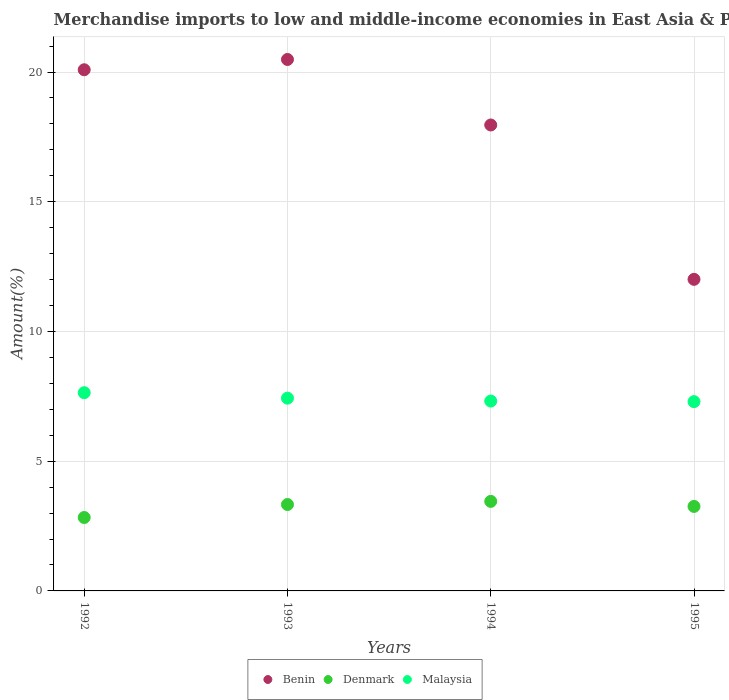How many different coloured dotlines are there?
Your answer should be very brief. 3. What is the percentage of amount earned from merchandise imports in Benin in 1993?
Make the answer very short. 20.48. Across all years, what is the maximum percentage of amount earned from merchandise imports in Denmark?
Give a very brief answer. 3.45. Across all years, what is the minimum percentage of amount earned from merchandise imports in Benin?
Give a very brief answer. 12.01. In which year was the percentage of amount earned from merchandise imports in Denmark maximum?
Ensure brevity in your answer.  1994. In which year was the percentage of amount earned from merchandise imports in Benin minimum?
Keep it short and to the point. 1995. What is the total percentage of amount earned from merchandise imports in Malaysia in the graph?
Give a very brief answer. 29.68. What is the difference between the percentage of amount earned from merchandise imports in Malaysia in 1994 and that in 1995?
Your answer should be very brief. 0.02. What is the difference between the percentage of amount earned from merchandise imports in Malaysia in 1992 and the percentage of amount earned from merchandise imports in Benin in 1994?
Your answer should be very brief. -10.32. What is the average percentage of amount earned from merchandise imports in Denmark per year?
Make the answer very short. 3.22. In the year 1993, what is the difference between the percentage of amount earned from merchandise imports in Benin and percentage of amount earned from merchandise imports in Malaysia?
Provide a succinct answer. 13.05. In how many years, is the percentage of amount earned from merchandise imports in Benin greater than 11 %?
Your answer should be very brief. 4. What is the ratio of the percentage of amount earned from merchandise imports in Denmark in 1992 to that in 1995?
Give a very brief answer. 0.87. Is the percentage of amount earned from merchandise imports in Benin in 1993 less than that in 1995?
Your answer should be compact. No. Is the difference between the percentage of amount earned from merchandise imports in Benin in 1992 and 1994 greater than the difference between the percentage of amount earned from merchandise imports in Malaysia in 1992 and 1994?
Offer a very short reply. Yes. What is the difference between the highest and the second highest percentage of amount earned from merchandise imports in Malaysia?
Your answer should be very brief. 0.21. What is the difference between the highest and the lowest percentage of amount earned from merchandise imports in Malaysia?
Your answer should be compact. 0.34. In how many years, is the percentage of amount earned from merchandise imports in Malaysia greater than the average percentage of amount earned from merchandise imports in Malaysia taken over all years?
Provide a succinct answer. 2. Is the sum of the percentage of amount earned from merchandise imports in Benin in 1993 and 1994 greater than the maximum percentage of amount earned from merchandise imports in Denmark across all years?
Make the answer very short. Yes. Is it the case that in every year, the sum of the percentage of amount earned from merchandise imports in Malaysia and percentage of amount earned from merchandise imports in Denmark  is greater than the percentage of amount earned from merchandise imports in Benin?
Give a very brief answer. No. Is the percentage of amount earned from merchandise imports in Denmark strictly greater than the percentage of amount earned from merchandise imports in Malaysia over the years?
Your answer should be very brief. No. Are the values on the major ticks of Y-axis written in scientific E-notation?
Your response must be concise. No. Does the graph contain any zero values?
Provide a short and direct response. No. How many legend labels are there?
Your answer should be compact. 3. What is the title of the graph?
Your answer should be very brief. Merchandise imports to low and middle-income economies in East Asia & Pacific. What is the label or title of the Y-axis?
Give a very brief answer. Amount(%). What is the Amount(%) in Benin in 1992?
Give a very brief answer. 20.09. What is the Amount(%) of Denmark in 1992?
Give a very brief answer. 2.83. What is the Amount(%) of Malaysia in 1992?
Give a very brief answer. 7.64. What is the Amount(%) in Benin in 1993?
Offer a very short reply. 20.48. What is the Amount(%) in Denmark in 1993?
Your response must be concise. 3.33. What is the Amount(%) in Malaysia in 1993?
Offer a terse response. 7.43. What is the Amount(%) in Benin in 1994?
Keep it short and to the point. 17.96. What is the Amount(%) of Denmark in 1994?
Offer a terse response. 3.45. What is the Amount(%) in Malaysia in 1994?
Your answer should be compact. 7.32. What is the Amount(%) in Benin in 1995?
Make the answer very short. 12.01. What is the Amount(%) in Denmark in 1995?
Your answer should be compact. 3.26. What is the Amount(%) in Malaysia in 1995?
Give a very brief answer. 7.3. Across all years, what is the maximum Amount(%) of Benin?
Keep it short and to the point. 20.48. Across all years, what is the maximum Amount(%) of Denmark?
Your answer should be compact. 3.45. Across all years, what is the maximum Amount(%) of Malaysia?
Offer a terse response. 7.64. Across all years, what is the minimum Amount(%) of Benin?
Make the answer very short. 12.01. Across all years, what is the minimum Amount(%) in Denmark?
Your answer should be compact. 2.83. Across all years, what is the minimum Amount(%) of Malaysia?
Keep it short and to the point. 7.3. What is the total Amount(%) of Benin in the graph?
Offer a terse response. 70.54. What is the total Amount(%) of Denmark in the graph?
Offer a very short reply. 12.87. What is the total Amount(%) in Malaysia in the graph?
Your answer should be very brief. 29.68. What is the difference between the Amount(%) in Benin in 1992 and that in 1993?
Your response must be concise. -0.4. What is the difference between the Amount(%) of Denmark in 1992 and that in 1993?
Offer a very short reply. -0.5. What is the difference between the Amount(%) of Malaysia in 1992 and that in 1993?
Your response must be concise. 0.21. What is the difference between the Amount(%) of Benin in 1992 and that in 1994?
Offer a very short reply. 2.13. What is the difference between the Amount(%) of Denmark in 1992 and that in 1994?
Provide a short and direct response. -0.62. What is the difference between the Amount(%) of Malaysia in 1992 and that in 1994?
Give a very brief answer. 0.32. What is the difference between the Amount(%) in Benin in 1992 and that in 1995?
Give a very brief answer. 8.08. What is the difference between the Amount(%) of Denmark in 1992 and that in 1995?
Offer a terse response. -0.43. What is the difference between the Amount(%) of Malaysia in 1992 and that in 1995?
Ensure brevity in your answer.  0.34. What is the difference between the Amount(%) in Benin in 1993 and that in 1994?
Ensure brevity in your answer.  2.52. What is the difference between the Amount(%) of Denmark in 1993 and that in 1994?
Give a very brief answer. -0.12. What is the difference between the Amount(%) in Malaysia in 1993 and that in 1994?
Provide a short and direct response. 0.11. What is the difference between the Amount(%) in Benin in 1993 and that in 1995?
Make the answer very short. 8.47. What is the difference between the Amount(%) of Denmark in 1993 and that in 1995?
Your response must be concise. 0.07. What is the difference between the Amount(%) in Malaysia in 1993 and that in 1995?
Give a very brief answer. 0.13. What is the difference between the Amount(%) in Benin in 1994 and that in 1995?
Your answer should be compact. 5.95. What is the difference between the Amount(%) in Denmark in 1994 and that in 1995?
Your answer should be compact. 0.19. What is the difference between the Amount(%) of Malaysia in 1994 and that in 1995?
Give a very brief answer. 0.02. What is the difference between the Amount(%) in Benin in 1992 and the Amount(%) in Denmark in 1993?
Your answer should be very brief. 16.76. What is the difference between the Amount(%) of Benin in 1992 and the Amount(%) of Malaysia in 1993?
Your answer should be very brief. 12.66. What is the difference between the Amount(%) of Denmark in 1992 and the Amount(%) of Malaysia in 1993?
Give a very brief answer. -4.6. What is the difference between the Amount(%) of Benin in 1992 and the Amount(%) of Denmark in 1994?
Ensure brevity in your answer.  16.64. What is the difference between the Amount(%) of Benin in 1992 and the Amount(%) of Malaysia in 1994?
Offer a terse response. 12.77. What is the difference between the Amount(%) of Denmark in 1992 and the Amount(%) of Malaysia in 1994?
Offer a very short reply. -4.49. What is the difference between the Amount(%) of Benin in 1992 and the Amount(%) of Denmark in 1995?
Provide a succinct answer. 16.83. What is the difference between the Amount(%) in Benin in 1992 and the Amount(%) in Malaysia in 1995?
Provide a succinct answer. 12.79. What is the difference between the Amount(%) of Denmark in 1992 and the Amount(%) of Malaysia in 1995?
Provide a succinct answer. -4.47. What is the difference between the Amount(%) in Benin in 1993 and the Amount(%) in Denmark in 1994?
Offer a very short reply. 17.03. What is the difference between the Amount(%) of Benin in 1993 and the Amount(%) of Malaysia in 1994?
Keep it short and to the point. 13.17. What is the difference between the Amount(%) in Denmark in 1993 and the Amount(%) in Malaysia in 1994?
Ensure brevity in your answer.  -3.99. What is the difference between the Amount(%) in Benin in 1993 and the Amount(%) in Denmark in 1995?
Offer a very short reply. 17.23. What is the difference between the Amount(%) of Benin in 1993 and the Amount(%) of Malaysia in 1995?
Provide a succinct answer. 13.19. What is the difference between the Amount(%) of Denmark in 1993 and the Amount(%) of Malaysia in 1995?
Keep it short and to the point. -3.97. What is the difference between the Amount(%) of Benin in 1994 and the Amount(%) of Denmark in 1995?
Give a very brief answer. 14.7. What is the difference between the Amount(%) of Benin in 1994 and the Amount(%) of Malaysia in 1995?
Your response must be concise. 10.66. What is the difference between the Amount(%) of Denmark in 1994 and the Amount(%) of Malaysia in 1995?
Provide a succinct answer. -3.84. What is the average Amount(%) in Benin per year?
Your response must be concise. 17.63. What is the average Amount(%) in Denmark per year?
Offer a very short reply. 3.22. What is the average Amount(%) of Malaysia per year?
Your answer should be very brief. 7.42. In the year 1992, what is the difference between the Amount(%) in Benin and Amount(%) in Denmark?
Make the answer very short. 17.26. In the year 1992, what is the difference between the Amount(%) in Benin and Amount(%) in Malaysia?
Keep it short and to the point. 12.45. In the year 1992, what is the difference between the Amount(%) in Denmark and Amount(%) in Malaysia?
Offer a very short reply. -4.81. In the year 1993, what is the difference between the Amount(%) of Benin and Amount(%) of Denmark?
Your answer should be very brief. 17.15. In the year 1993, what is the difference between the Amount(%) of Benin and Amount(%) of Malaysia?
Offer a very short reply. 13.05. In the year 1993, what is the difference between the Amount(%) of Denmark and Amount(%) of Malaysia?
Your answer should be compact. -4.1. In the year 1994, what is the difference between the Amount(%) in Benin and Amount(%) in Denmark?
Your answer should be compact. 14.51. In the year 1994, what is the difference between the Amount(%) of Benin and Amount(%) of Malaysia?
Your response must be concise. 10.64. In the year 1994, what is the difference between the Amount(%) in Denmark and Amount(%) in Malaysia?
Your response must be concise. -3.87. In the year 1995, what is the difference between the Amount(%) of Benin and Amount(%) of Denmark?
Make the answer very short. 8.75. In the year 1995, what is the difference between the Amount(%) in Benin and Amount(%) in Malaysia?
Your response must be concise. 4.71. In the year 1995, what is the difference between the Amount(%) in Denmark and Amount(%) in Malaysia?
Offer a terse response. -4.04. What is the ratio of the Amount(%) of Benin in 1992 to that in 1993?
Make the answer very short. 0.98. What is the ratio of the Amount(%) of Denmark in 1992 to that in 1993?
Provide a short and direct response. 0.85. What is the ratio of the Amount(%) of Malaysia in 1992 to that in 1993?
Your answer should be very brief. 1.03. What is the ratio of the Amount(%) of Benin in 1992 to that in 1994?
Provide a short and direct response. 1.12. What is the ratio of the Amount(%) in Denmark in 1992 to that in 1994?
Give a very brief answer. 0.82. What is the ratio of the Amount(%) of Malaysia in 1992 to that in 1994?
Your answer should be very brief. 1.04. What is the ratio of the Amount(%) of Benin in 1992 to that in 1995?
Offer a very short reply. 1.67. What is the ratio of the Amount(%) in Denmark in 1992 to that in 1995?
Ensure brevity in your answer.  0.87. What is the ratio of the Amount(%) in Malaysia in 1992 to that in 1995?
Provide a short and direct response. 1.05. What is the ratio of the Amount(%) of Benin in 1993 to that in 1994?
Ensure brevity in your answer.  1.14. What is the ratio of the Amount(%) of Malaysia in 1993 to that in 1994?
Keep it short and to the point. 1.02. What is the ratio of the Amount(%) in Benin in 1993 to that in 1995?
Your answer should be very brief. 1.71. What is the ratio of the Amount(%) of Denmark in 1993 to that in 1995?
Your answer should be compact. 1.02. What is the ratio of the Amount(%) in Malaysia in 1993 to that in 1995?
Provide a short and direct response. 1.02. What is the ratio of the Amount(%) of Benin in 1994 to that in 1995?
Offer a very short reply. 1.5. What is the ratio of the Amount(%) in Denmark in 1994 to that in 1995?
Give a very brief answer. 1.06. What is the ratio of the Amount(%) in Malaysia in 1994 to that in 1995?
Make the answer very short. 1. What is the difference between the highest and the second highest Amount(%) in Benin?
Keep it short and to the point. 0.4. What is the difference between the highest and the second highest Amount(%) in Denmark?
Make the answer very short. 0.12. What is the difference between the highest and the second highest Amount(%) in Malaysia?
Offer a very short reply. 0.21. What is the difference between the highest and the lowest Amount(%) of Benin?
Keep it short and to the point. 8.47. What is the difference between the highest and the lowest Amount(%) in Denmark?
Give a very brief answer. 0.62. What is the difference between the highest and the lowest Amount(%) of Malaysia?
Provide a short and direct response. 0.34. 